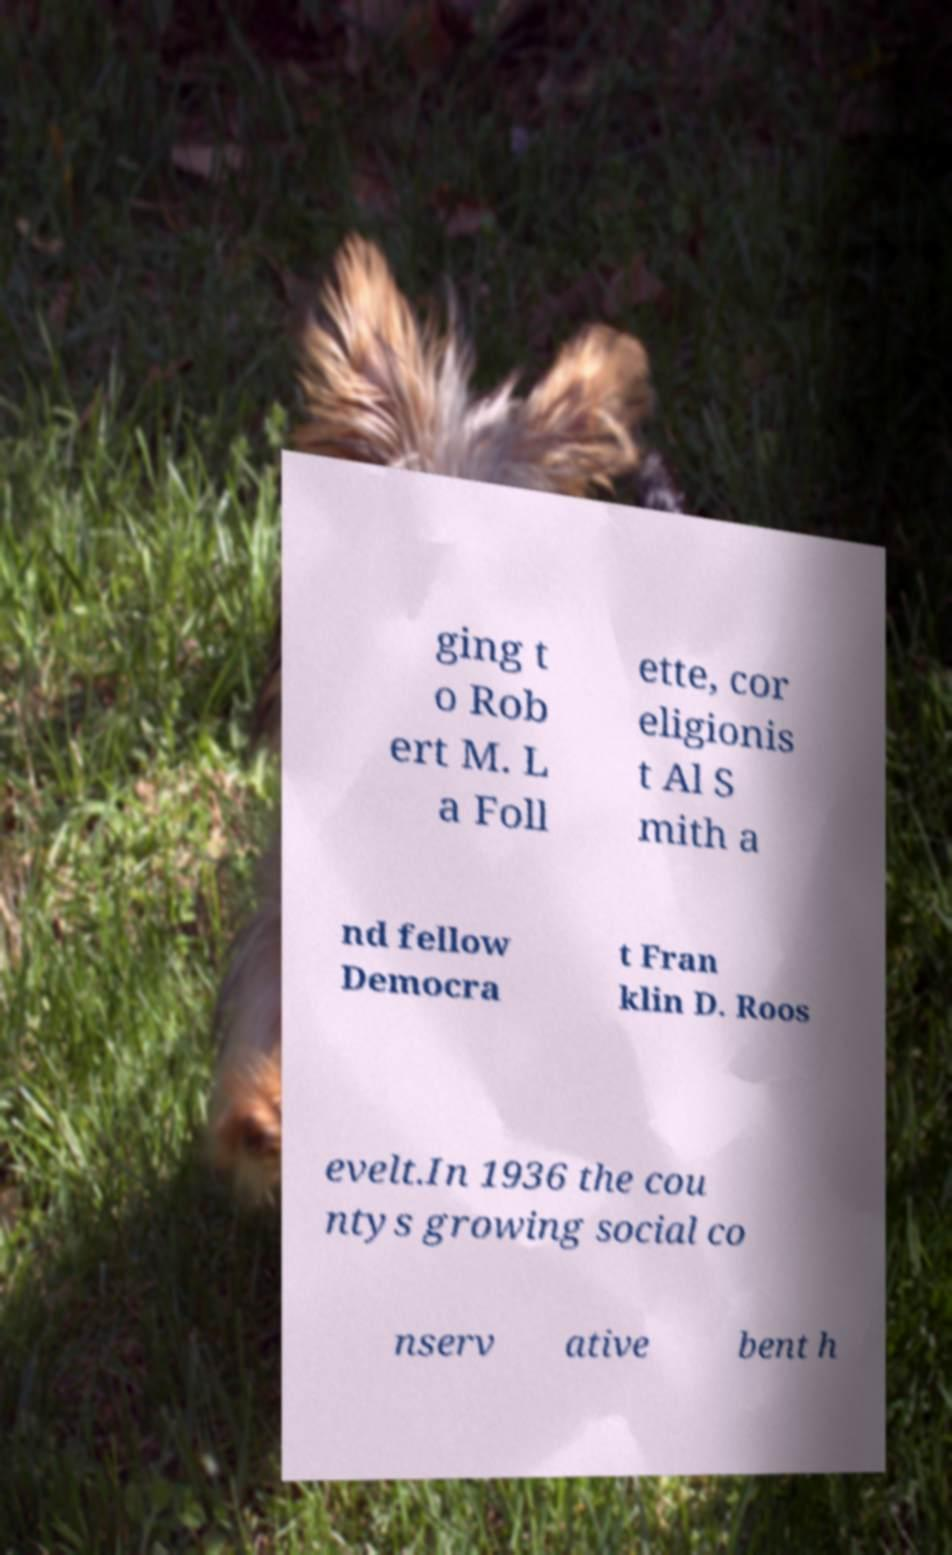What messages or text are displayed in this image? I need them in a readable, typed format. ging t o Rob ert M. L a Foll ette, cor eligionis t Al S mith a nd fellow Democra t Fran klin D. Roos evelt.In 1936 the cou ntys growing social co nserv ative bent h 